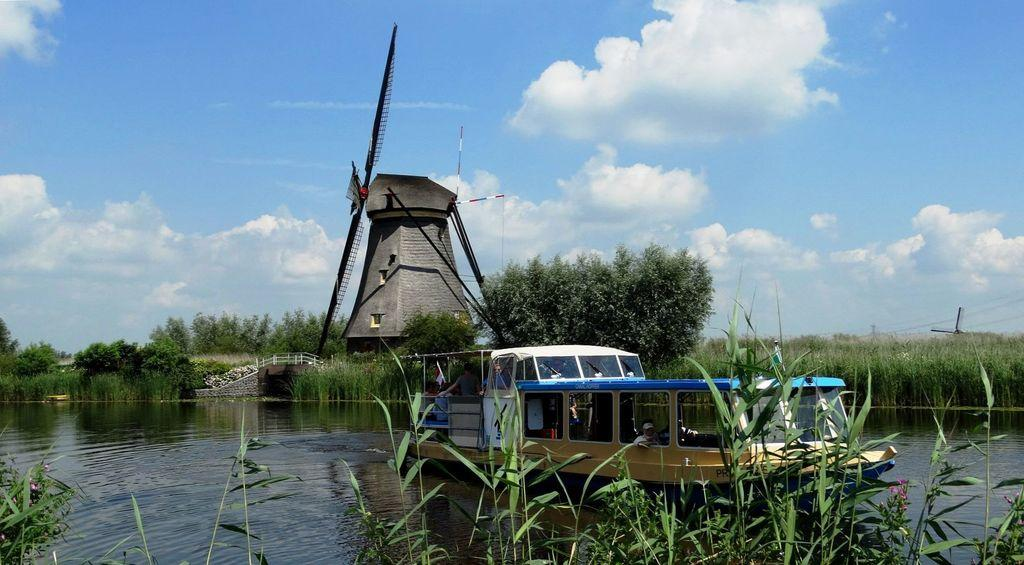What type of living organisms can be seen in the image? Plants can be seen in the image. What are the people in the image doing? The people are sitting in a ship. Where is the ship located in the image? The ship is on a river. What can be seen in the background of the image? Trees, windmills, and the sky are visible in the background of the image. Who is the creator of the windmills in the image? There is no information about the creator of the windmills in the image. What attempt is being made by the people sitting in the ship? There is no indication of an attempt being made by the people sitting in the ship in the image. 